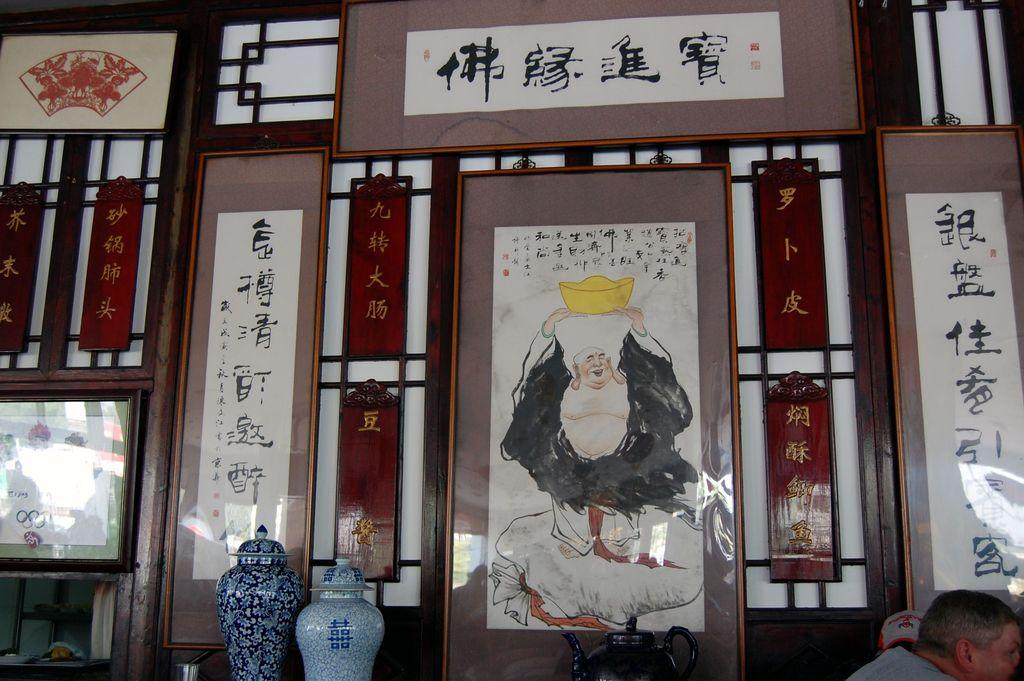What can be seen in the image that comes in different colors? There are frames in different colors in the image. What color are the two bases in the image? The two bases in the image are blue. Is there a person present in the image? Yes, there is a person in the image. Can you tell me how many buttons are on the person's shirt in the image? There is no information about buttons or a shirt in the image; it only mentions frames, bases, and a person. Is there a river visible in the image? There is no river present in the image. 